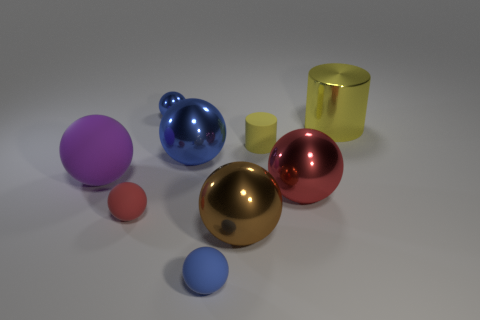Is the color of the matte thing to the right of the blue matte object the same as the metallic cylinder?
Give a very brief answer. Yes. How many other objects are the same material as the big cylinder?
Give a very brief answer. 4. How big is the red object on the right side of the small blue rubber sphere?
Offer a terse response. Large. Is the color of the large cylinder the same as the small cylinder?
Make the answer very short. Yes. What number of tiny objects are either blue balls or rubber cylinders?
Ensure brevity in your answer.  3. Are there any other things that have the same color as the small metallic object?
Give a very brief answer. Yes. There is a small cylinder; are there any yellow objects left of it?
Offer a terse response. No. There is a yellow cylinder that is left of the cylinder that is behind the tiny cylinder; how big is it?
Give a very brief answer. Small. Are there an equal number of large blue shiny things behind the large blue shiny object and blue spheres that are right of the yellow matte cylinder?
Your response must be concise. Yes. Are there any big purple matte balls that are in front of the matte sphere that is to the left of the red matte object?
Provide a short and direct response. No. 